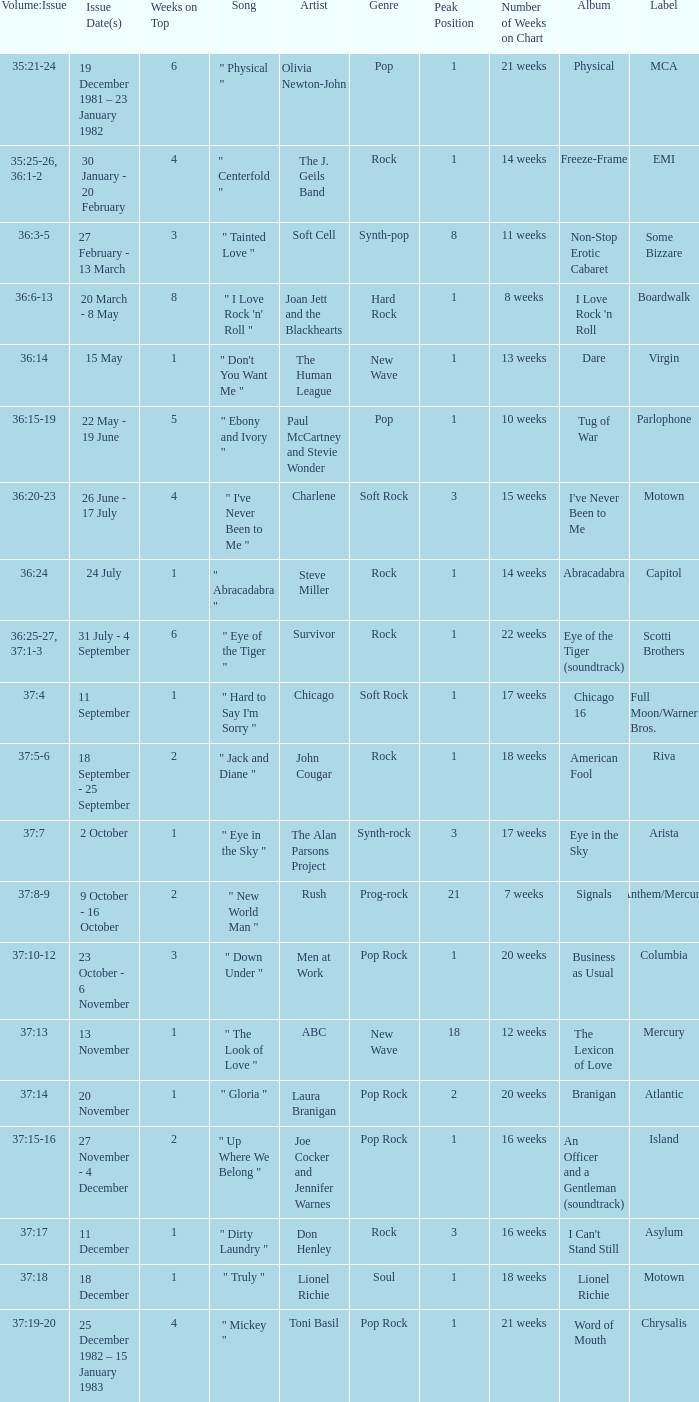Which Weeks on Top have an Issue Date(s) of 20 november? 1.0. 